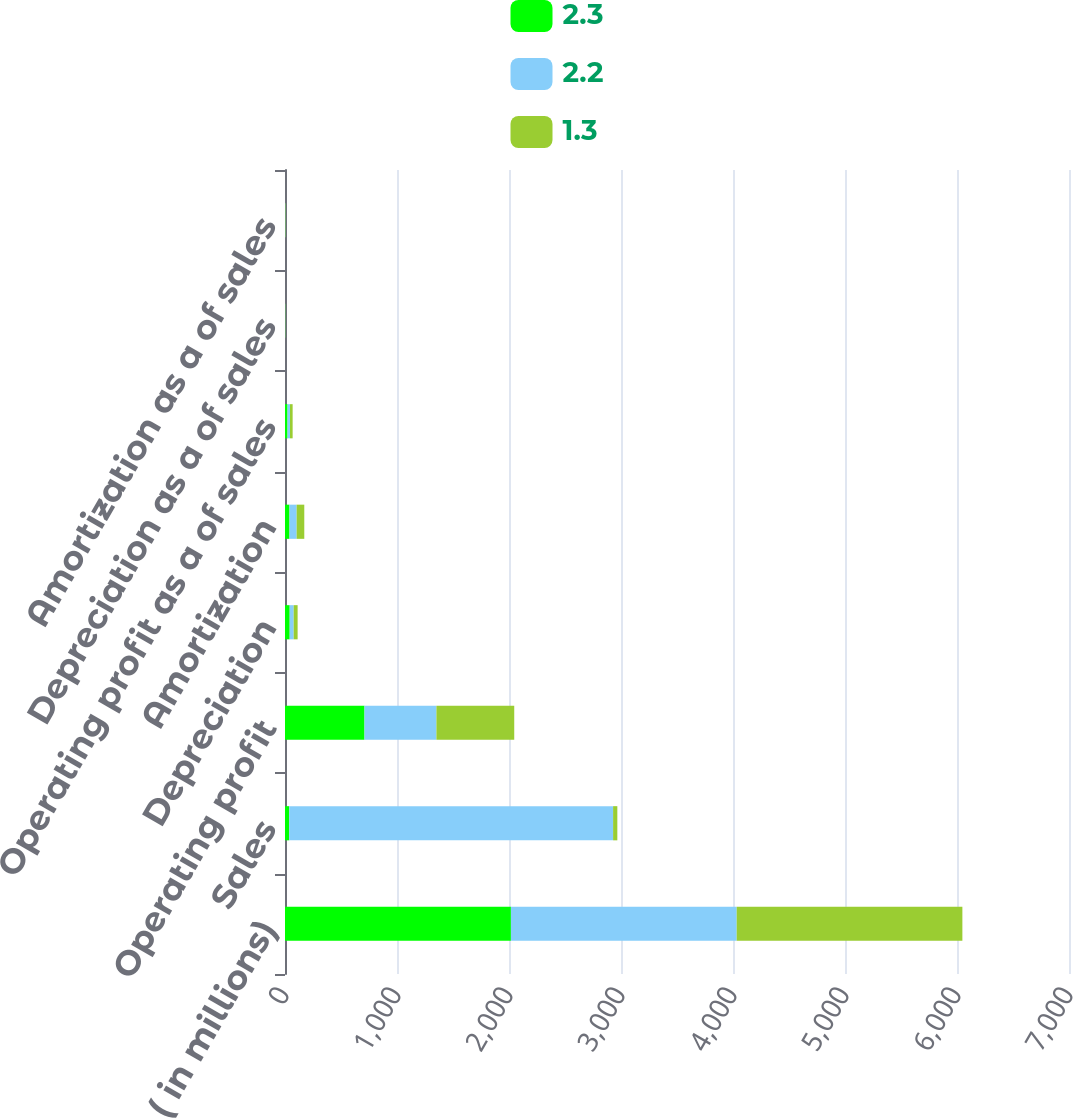<chart> <loc_0><loc_0><loc_500><loc_500><stacked_bar_chart><ecel><fcel>( in millions)<fcel>Sales<fcel>Operating profit<fcel>Depreciation<fcel>Amortization<fcel>Operating profit as a of sales<fcel>Depreciation as a of sales<fcel>Amortization as a of sales<nl><fcel>2.3<fcel>2017<fcel>37.85<fcel>709.7<fcel>41.9<fcel>40.1<fcel>22.6<fcel>1.3<fcel>1.3<nl><fcel>2.2<fcel>2016<fcel>2891.6<fcel>642.3<fcel>35.6<fcel>63.8<fcel>22.2<fcel>1.2<fcel>2.2<nl><fcel>1.3<fcel>2015<fcel>37.85<fcel>694.8<fcel>35.2<fcel>68.3<fcel>23.4<fcel>1.2<fcel>2.3<nl></chart> 